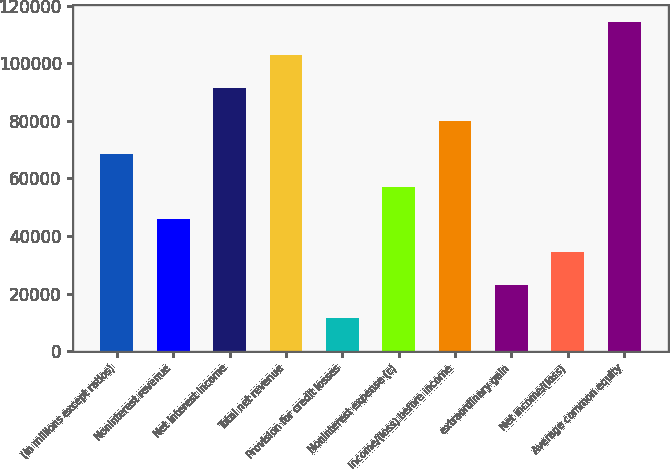Convert chart. <chart><loc_0><loc_0><loc_500><loc_500><bar_chart><fcel>(in millions except ratios)<fcel>Noninterest revenue<fcel>Net interest income<fcel>Total net revenue<fcel>Provision for credit losses<fcel>Noninterest expense (c)<fcel>Income/(loss) before income<fcel>extraordinary gain<fcel>Net income/(loss)<fcel>Average common equity<nl><fcel>68595.8<fcel>45744.2<fcel>91447.4<fcel>102873<fcel>11466.8<fcel>57170<fcel>80021.6<fcel>22892.6<fcel>34318.4<fcel>114299<nl></chart> 